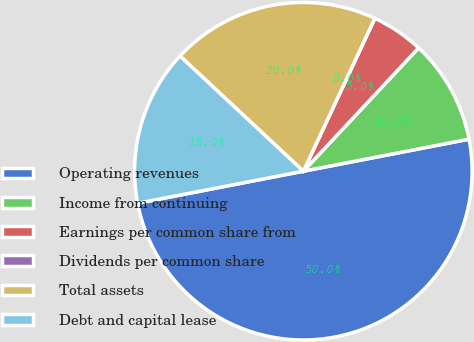Convert chart. <chart><loc_0><loc_0><loc_500><loc_500><pie_chart><fcel>Operating revenues<fcel>Income from continuing<fcel>Earnings per common share from<fcel>Dividends per common share<fcel>Total assets<fcel>Debt and capital lease<nl><fcel>50.0%<fcel>10.0%<fcel>5.0%<fcel>0.0%<fcel>20.0%<fcel>15.0%<nl></chart> 